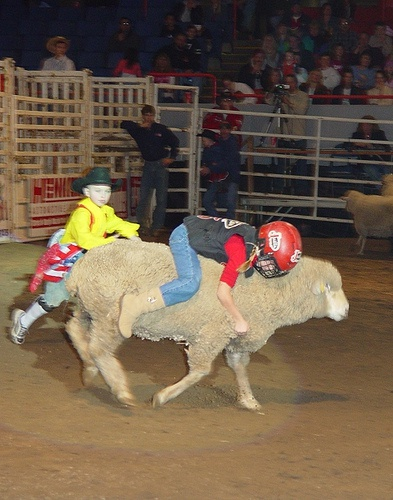Describe the objects in this image and their specific colors. I can see sheep in black and tan tones, people in black, maroon, and gray tones, people in black, gray, and tan tones, people in black, yellow, darkgray, and lightgray tones, and people in black, maroon, and gray tones in this image. 